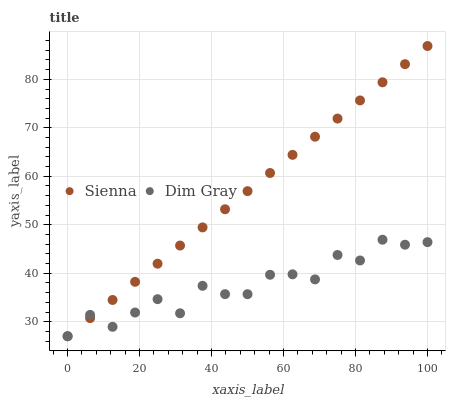Does Dim Gray have the minimum area under the curve?
Answer yes or no. Yes. Does Sienna have the maximum area under the curve?
Answer yes or no. Yes. Does Dim Gray have the maximum area under the curve?
Answer yes or no. No. Is Sienna the smoothest?
Answer yes or no. Yes. Is Dim Gray the roughest?
Answer yes or no. Yes. Is Dim Gray the smoothest?
Answer yes or no. No. Does Sienna have the lowest value?
Answer yes or no. Yes. Does Sienna have the highest value?
Answer yes or no. Yes. Does Dim Gray have the highest value?
Answer yes or no. No. Does Sienna intersect Dim Gray?
Answer yes or no. Yes. Is Sienna less than Dim Gray?
Answer yes or no. No. Is Sienna greater than Dim Gray?
Answer yes or no. No. 